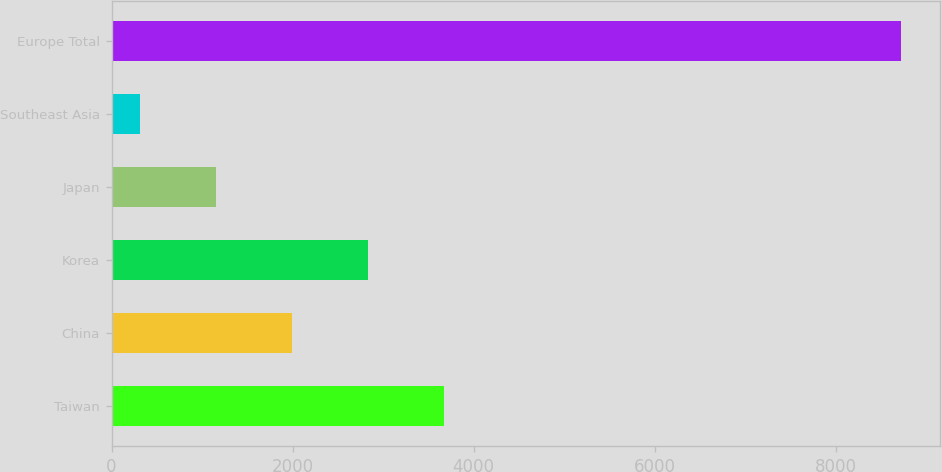Convert chart. <chart><loc_0><loc_0><loc_500><loc_500><bar_chart><fcel>Taiwan<fcel>China<fcel>Korea<fcel>Japan<fcel>Southeast Asia<fcel>Europe Total<nl><fcel>3674.8<fcel>1993.4<fcel>2834.1<fcel>1152.7<fcel>312<fcel>8719<nl></chart> 